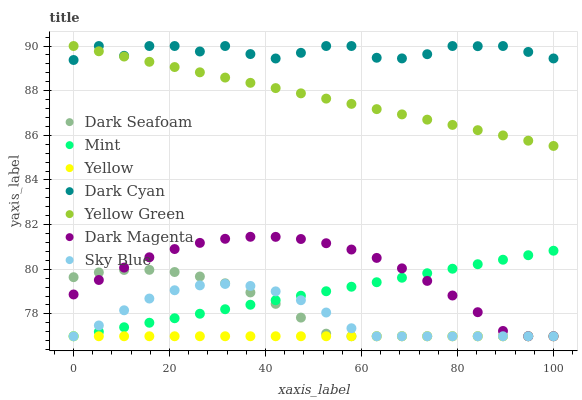Does Yellow have the minimum area under the curve?
Answer yes or no. Yes. Does Dark Cyan have the maximum area under the curve?
Answer yes or no. Yes. Does Dark Seafoam have the minimum area under the curve?
Answer yes or no. No. Does Dark Seafoam have the maximum area under the curve?
Answer yes or no. No. Is Yellow the smoothest?
Answer yes or no. Yes. Is Dark Cyan the roughest?
Answer yes or no. Yes. Is Dark Seafoam the smoothest?
Answer yes or no. No. Is Dark Seafoam the roughest?
Answer yes or no. No. Does Yellow have the lowest value?
Answer yes or no. Yes. Does Dark Cyan have the lowest value?
Answer yes or no. No. Does Dark Cyan have the highest value?
Answer yes or no. Yes. Does Dark Seafoam have the highest value?
Answer yes or no. No. Is Sky Blue less than Yellow Green?
Answer yes or no. Yes. Is Dark Cyan greater than Dark Seafoam?
Answer yes or no. Yes. Does Dark Seafoam intersect Sky Blue?
Answer yes or no. Yes. Is Dark Seafoam less than Sky Blue?
Answer yes or no. No. Is Dark Seafoam greater than Sky Blue?
Answer yes or no. No. Does Sky Blue intersect Yellow Green?
Answer yes or no. No. 